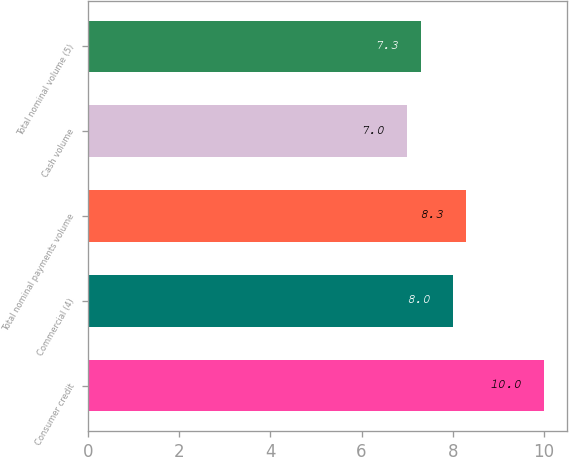Convert chart. <chart><loc_0><loc_0><loc_500><loc_500><bar_chart><fcel>Consumer credit<fcel>Commercial (4)<fcel>Total nominal payments volume<fcel>Cash volume<fcel>Total nominal volume (5)<nl><fcel>10<fcel>8<fcel>8.3<fcel>7<fcel>7.3<nl></chart> 